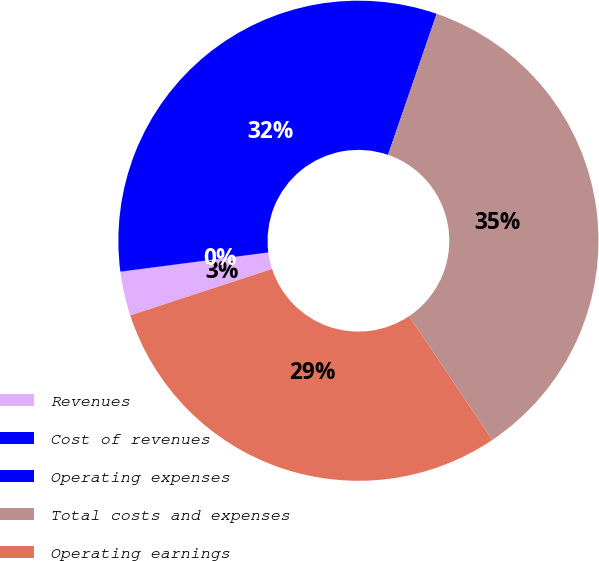Convert chart to OTSL. <chart><loc_0><loc_0><loc_500><loc_500><pie_chart><fcel>Revenues<fcel>Cost of revenues<fcel>Operating expenses<fcel>Total costs and expenses<fcel>Operating earnings<nl><fcel>2.97%<fcel>0.01%<fcel>32.34%<fcel>35.3%<fcel>29.38%<nl></chart> 